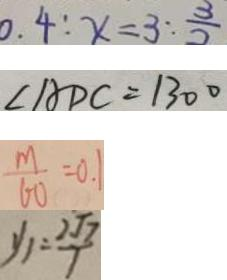<formula> <loc_0><loc_0><loc_500><loc_500>0 . 4 : x = 3 : \frac { 3 } { 2 } 
 \angle A D C = 1 3 0 ^ { \circ } 
 \frac { m } { 6 0 } = 0 . 1 
 y _ { 1 } = \frac { 2 \sqrt { 7 } } { 7 }</formula> 